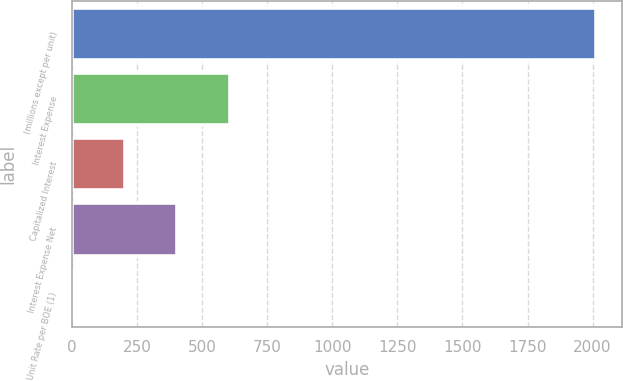Convert chart. <chart><loc_0><loc_0><loc_500><loc_500><bar_chart><fcel>(millions except per unit)<fcel>Interest Expense<fcel>Capitalized Interest<fcel>Interest Expense Net<fcel>Unit Rate per BOE (1)<nl><fcel>2013<fcel>605.05<fcel>202.77<fcel>403.91<fcel>1.63<nl></chart> 